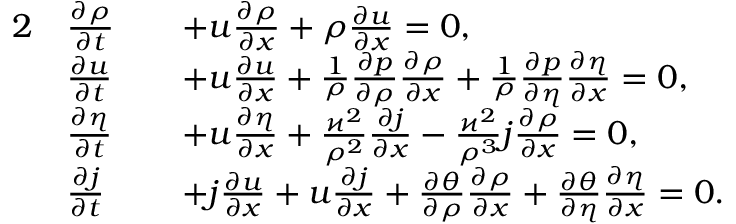Convert formula to latex. <formula><loc_0><loc_0><loc_500><loc_500>\begin{array} { r l r l } { 2 } & { \frac { \partial \rho } { \partial t } } & & { + u \frac { \partial \rho } { \partial x } + \rho \frac { \partial u } { \partial x } = 0 , } \\ & { \frac { \partial u } { \partial t } } & & { + u \frac { \partial u } { \partial x } + \frac { 1 } { \rho } \frac { \partial p } { \partial \rho } \frac { \partial \rho } { \partial x } + \frac { 1 } { \rho } \frac { \partial p } { \partial \eta } \frac { \partial \eta } { \partial x } = 0 , } \\ & { \frac { \partial \eta } { \partial t } } & & { + u \frac { \partial \eta } { \partial x } + \frac { \varkappa ^ { 2 } } { \rho ^ { 2 } } \frac { \partial j } { \partial x } - \frac { \varkappa ^ { 2 } } { \rho ^ { 3 } } j \frac { \partial \rho } { \partial x } = 0 , } \\ & { \frac { \partial j } { \partial t } } & & { + j \frac { \partial u } { \partial x } + u \frac { \partial j } { \partial x } + \frac { \partial \theta } { \partial \rho } \frac { \partial \rho } { \partial x } + \frac { \partial \theta } { \partial \eta } \frac { \partial \eta } { \partial x } = 0 . } \end{array}</formula> 